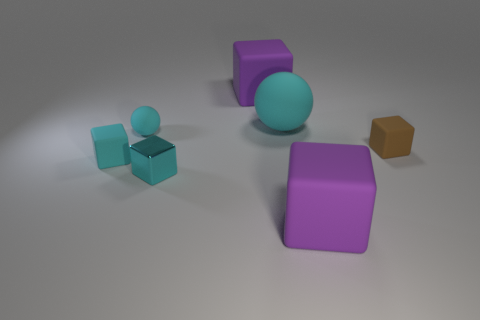The large sphere that is made of the same material as the brown cube is what color?
Your answer should be very brief. Cyan. Is the number of tiny brown matte things that are in front of the small cyan matte block greater than the number of large purple rubber cubes that are behind the big cyan matte thing?
Provide a succinct answer. No. Are any tiny brown blocks visible?
Keep it short and to the point. Yes. There is a big sphere that is the same color as the tiny metallic cube; what is it made of?
Your answer should be very brief. Rubber. How many things are either tiny cyan objects or small metallic cubes?
Provide a succinct answer. 3. Is there a small shiny block that has the same color as the metal thing?
Make the answer very short. No. What number of brown matte objects are in front of the purple matte thing that is in front of the metallic block?
Give a very brief answer. 0. Are there more small metallic objects than yellow cylinders?
Provide a succinct answer. Yes. Are the large ball and the tiny brown object made of the same material?
Give a very brief answer. Yes. Are there the same number of big cubes that are in front of the brown thing and small cyan matte spheres?
Your answer should be compact. Yes. 